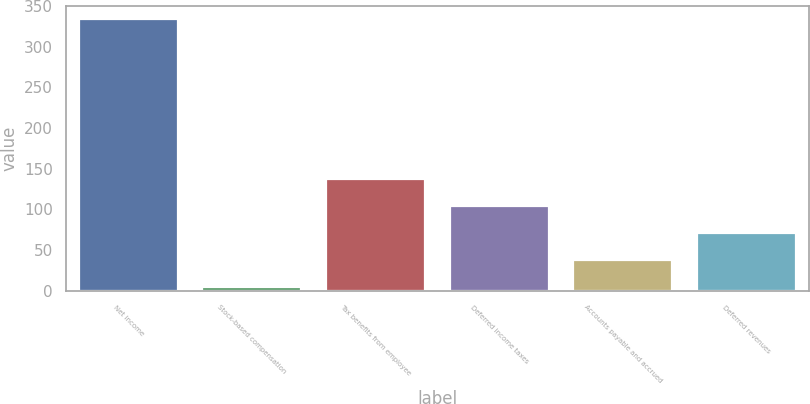Convert chart. <chart><loc_0><loc_0><loc_500><loc_500><bar_chart><fcel>Net income<fcel>Stock-based compensation<fcel>Tax benefits from employee<fcel>Deferred income taxes<fcel>Accounts payable and accrued<fcel>Deferred revenues<nl><fcel>333.6<fcel>4.6<fcel>137.5<fcel>104.6<fcel>37.5<fcel>71.7<nl></chart> 